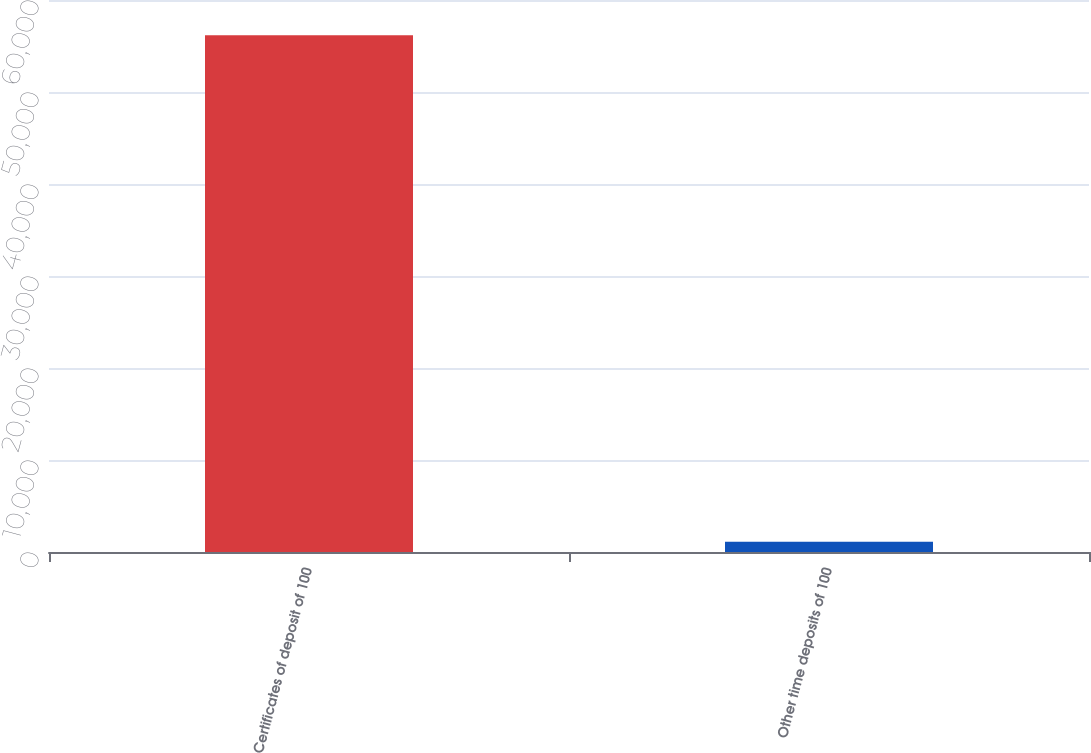Convert chart to OTSL. <chart><loc_0><loc_0><loc_500><loc_500><bar_chart><fcel>Certificates of deposit of 100<fcel>Other time deposits of 100<nl><fcel>56155<fcel>1125<nl></chart> 